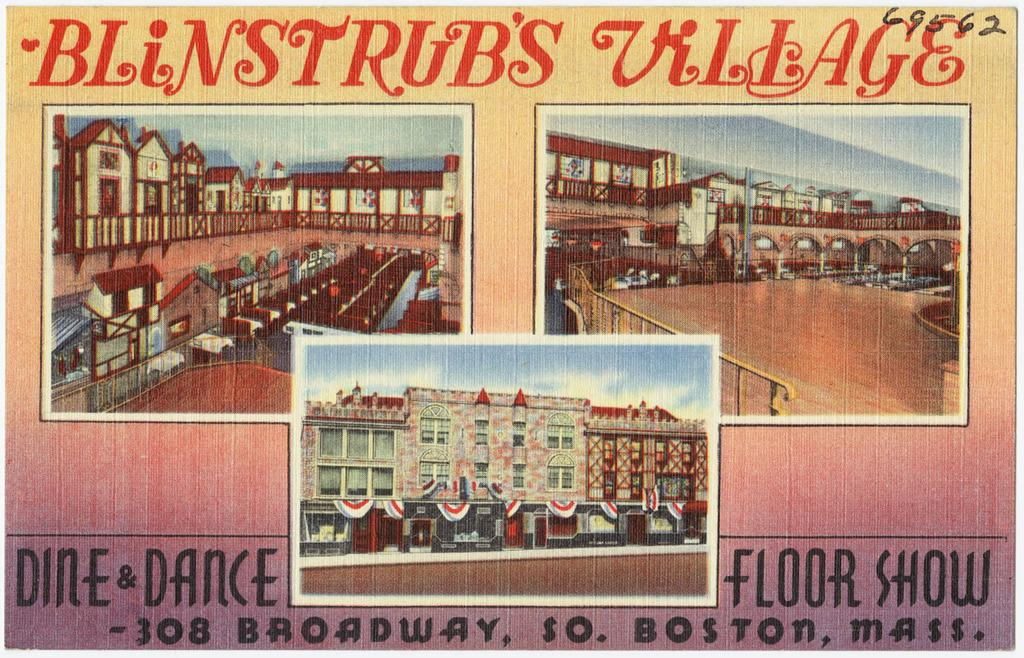<image>
Give a short and clear explanation of the subsequent image. An oldfashioned postcard for Blinstrub's village in Boston shows quaint storefronts and townhouses. 